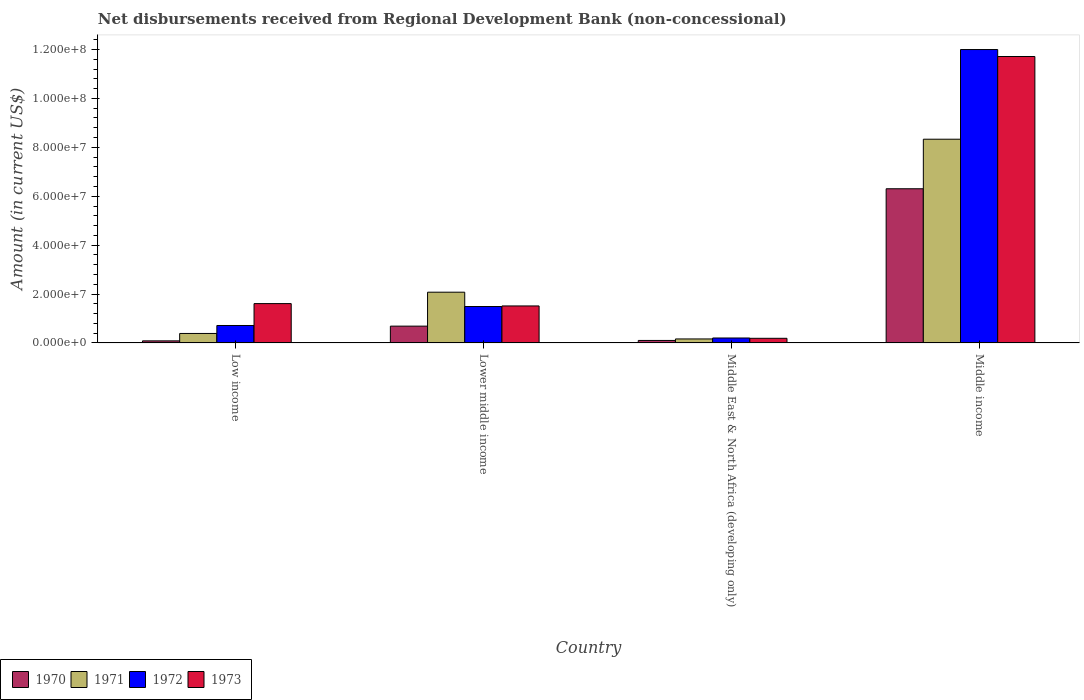Are the number of bars per tick equal to the number of legend labels?
Keep it short and to the point. Yes. How many bars are there on the 3rd tick from the left?
Provide a succinct answer. 4. How many bars are there on the 1st tick from the right?
Your answer should be compact. 4. What is the label of the 4th group of bars from the left?
Offer a terse response. Middle income. What is the amount of disbursements received from Regional Development Bank in 1973 in Middle income?
Keep it short and to the point. 1.17e+08. Across all countries, what is the maximum amount of disbursements received from Regional Development Bank in 1971?
Offer a very short reply. 8.33e+07. Across all countries, what is the minimum amount of disbursements received from Regional Development Bank in 1970?
Provide a succinct answer. 8.50e+05. In which country was the amount of disbursements received from Regional Development Bank in 1972 maximum?
Offer a terse response. Middle income. In which country was the amount of disbursements received from Regional Development Bank in 1973 minimum?
Give a very brief answer. Middle East & North Africa (developing only). What is the total amount of disbursements received from Regional Development Bank in 1970 in the graph?
Your response must be concise. 7.18e+07. What is the difference between the amount of disbursements received from Regional Development Bank in 1972 in Low income and that in Middle East & North Africa (developing only)?
Your response must be concise. 5.11e+06. What is the difference between the amount of disbursements received from Regional Development Bank in 1973 in Low income and the amount of disbursements received from Regional Development Bank in 1972 in Lower middle income?
Make the answer very short. 1.19e+06. What is the average amount of disbursements received from Regional Development Bank in 1973 per country?
Keep it short and to the point. 3.76e+07. What is the difference between the amount of disbursements received from Regional Development Bank of/in 1972 and amount of disbursements received from Regional Development Bank of/in 1973 in Middle income?
Your answer should be compact. 2.85e+06. What is the ratio of the amount of disbursements received from Regional Development Bank in 1972 in Lower middle income to that in Middle East & North Africa (developing only)?
Provide a succinct answer. 7.36. Is the amount of disbursements received from Regional Development Bank in 1973 in Low income less than that in Middle East & North Africa (developing only)?
Keep it short and to the point. No. What is the difference between the highest and the second highest amount of disbursements received from Regional Development Bank in 1970?
Keep it short and to the point. 6.20e+07. What is the difference between the highest and the lowest amount of disbursements received from Regional Development Bank in 1970?
Ensure brevity in your answer.  6.22e+07. In how many countries, is the amount of disbursements received from Regional Development Bank in 1971 greater than the average amount of disbursements received from Regional Development Bank in 1971 taken over all countries?
Ensure brevity in your answer.  1. Is the sum of the amount of disbursements received from Regional Development Bank in 1973 in Low income and Middle East & North Africa (developing only) greater than the maximum amount of disbursements received from Regional Development Bank in 1971 across all countries?
Your answer should be very brief. No. How many bars are there?
Offer a terse response. 16. How many countries are there in the graph?
Offer a very short reply. 4. What is the difference between two consecutive major ticks on the Y-axis?
Offer a terse response. 2.00e+07. Are the values on the major ticks of Y-axis written in scientific E-notation?
Your answer should be very brief. Yes. Does the graph contain grids?
Keep it short and to the point. No. Where does the legend appear in the graph?
Offer a terse response. Bottom left. What is the title of the graph?
Your response must be concise. Net disbursements received from Regional Development Bank (non-concessional). What is the label or title of the Y-axis?
Your answer should be very brief. Amount (in current US$). What is the Amount (in current US$) of 1970 in Low income?
Offer a terse response. 8.50e+05. What is the Amount (in current US$) in 1971 in Low income?
Provide a short and direct response. 3.88e+06. What is the Amount (in current US$) of 1972 in Low income?
Ensure brevity in your answer.  7.14e+06. What is the Amount (in current US$) in 1973 in Low income?
Offer a terse response. 1.61e+07. What is the Amount (in current US$) of 1970 in Lower middle income?
Give a very brief answer. 6.87e+06. What is the Amount (in current US$) in 1971 in Lower middle income?
Provide a short and direct response. 2.08e+07. What is the Amount (in current US$) of 1972 in Lower middle income?
Your answer should be compact. 1.49e+07. What is the Amount (in current US$) of 1973 in Lower middle income?
Your response must be concise. 1.51e+07. What is the Amount (in current US$) in 1970 in Middle East & North Africa (developing only)?
Provide a short and direct response. 1.02e+06. What is the Amount (in current US$) of 1971 in Middle East & North Africa (developing only)?
Provide a short and direct response. 1.64e+06. What is the Amount (in current US$) in 1972 in Middle East & North Africa (developing only)?
Offer a very short reply. 2.02e+06. What is the Amount (in current US$) in 1973 in Middle East & North Africa (developing only)?
Offer a very short reply. 1.90e+06. What is the Amount (in current US$) in 1970 in Middle income?
Offer a very short reply. 6.31e+07. What is the Amount (in current US$) of 1971 in Middle income?
Give a very brief answer. 8.33e+07. What is the Amount (in current US$) in 1972 in Middle income?
Give a very brief answer. 1.20e+08. What is the Amount (in current US$) of 1973 in Middle income?
Offer a terse response. 1.17e+08. Across all countries, what is the maximum Amount (in current US$) in 1970?
Keep it short and to the point. 6.31e+07. Across all countries, what is the maximum Amount (in current US$) of 1971?
Your response must be concise. 8.33e+07. Across all countries, what is the maximum Amount (in current US$) in 1972?
Your answer should be very brief. 1.20e+08. Across all countries, what is the maximum Amount (in current US$) in 1973?
Offer a very short reply. 1.17e+08. Across all countries, what is the minimum Amount (in current US$) of 1970?
Offer a terse response. 8.50e+05. Across all countries, what is the minimum Amount (in current US$) in 1971?
Your answer should be very brief. 1.64e+06. Across all countries, what is the minimum Amount (in current US$) of 1972?
Your answer should be very brief. 2.02e+06. Across all countries, what is the minimum Amount (in current US$) in 1973?
Offer a very short reply. 1.90e+06. What is the total Amount (in current US$) of 1970 in the graph?
Make the answer very short. 7.18e+07. What is the total Amount (in current US$) of 1971 in the graph?
Provide a short and direct response. 1.10e+08. What is the total Amount (in current US$) in 1972 in the graph?
Provide a short and direct response. 1.44e+08. What is the total Amount (in current US$) in 1973 in the graph?
Provide a succinct answer. 1.50e+08. What is the difference between the Amount (in current US$) of 1970 in Low income and that in Lower middle income?
Give a very brief answer. -6.02e+06. What is the difference between the Amount (in current US$) in 1971 in Low income and that in Lower middle income?
Your answer should be very brief. -1.69e+07. What is the difference between the Amount (in current US$) in 1972 in Low income and that in Lower middle income?
Offer a terse response. -7.76e+06. What is the difference between the Amount (in current US$) in 1973 in Low income and that in Lower middle income?
Your answer should be compact. 9.55e+05. What is the difference between the Amount (in current US$) of 1970 in Low income and that in Middle East & North Africa (developing only)?
Give a very brief answer. -1.71e+05. What is the difference between the Amount (in current US$) in 1971 in Low income and that in Middle East & North Africa (developing only)?
Your answer should be very brief. 2.24e+06. What is the difference between the Amount (in current US$) in 1972 in Low income and that in Middle East & North Africa (developing only)?
Your answer should be compact. 5.11e+06. What is the difference between the Amount (in current US$) in 1973 in Low income and that in Middle East & North Africa (developing only)?
Your answer should be very brief. 1.42e+07. What is the difference between the Amount (in current US$) of 1970 in Low income and that in Middle income?
Provide a succinct answer. -6.22e+07. What is the difference between the Amount (in current US$) of 1971 in Low income and that in Middle income?
Make the answer very short. -7.94e+07. What is the difference between the Amount (in current US$) in 1972 in Low income and that in Middle income?
Offer a very short reply. -1.13e+08. What is the difference between the Amount (in current US$) of 1973 in Low income and that in Middle income?
Your answer should be compact. -1.01e+08. What is the difference between the Amount (in current US$) of 1970 in Lower middle income and that in Middle East & North Africa (developing only)?
Ensure brevity in your answer.  5.85e+06. What is the difference between the Amount (in current US$) of 1971 in Lower middle income and that in Middle East & North Africa (developing only)?
Keep it short and to the point. 1.91e+07. What is the difference between the Amount (in current US$) in 1972 in Lower middle income and that in Middle East & North Africa (developing only)?
Your answer should be compact. 1.29e+07. What is the difference between the Amount (in current US$) in 1973 in Lower middle income and that in Middle East & North Africa (developing only)?
Your answer should be very brief. 1.32e+07. What is the difference between the Amount (in current US$) of 1970 in Lower middle income and that in Middle income?
Offer a very short reply. -5.62e+07. What is the difference between the Amount (in current US$) in 1971 in Lower middle income and that in Middle income?
Your answer should be compact. -6.26e+07. What is the difference between the Amount (in current US$) in 1972 in Lower middle income and that in Middle income?
Your response must be concise. -1.05e+08. What is the difference between the Amount (in current US$) in 1973 in Lower middle income and that in Middle income?
Keep it short and to the point. -1.02e+08. What is the difference between the Amount (in current US$) in 1970 in Middle East & North Africa (developing only) and that in Middle income?
Give a very brief answer. -6.20e+07. What is the difference between the Amount (in current US$) of 1971 in Middle East & North Africa (developing only) and that in Middle income?
Make the answer very short. -8.17e+07. What is the difference between the Amount (in current US$) in 1972 in Middle East & North Africa (developing only) and that in Middle income?
Make the answer very short. -1.18e+08. What is the difference between the Amount (in current US$) of 1973 in Middle East & North Africa (developing only) and that in Middle income?
Your response must be concise. -1.15e+08. What is the difference between the Amount (in current US$) in 1970 in Low income and the Amount (in current US$) in 1971 in Lower middle income?
Make the answer very short. -1.99e+07. What is the difference between the Amount (in current US$) of 1970 in Low income and the Amount (in current US$) of 1972 in Lower middle income?
Provide a short and direct response. -1.40e+07. What is the difference between the Amount (in current US$) in 1970 in Low income and the Amount (in current US$) in 1973 in Lower middle income?
Give a very brief answer. -1.43e+07. What is the difference between the Amount (in current US$) of 1971 in Low income and the Amount (in current US$) of 1972 in Lower middle income?
Ensure brevity in your answer.  -1.10e+07. What is the difference between the Amount (in current US$) of 1971 in Low income and the Amount (in current US$) of 1973 in Lower middle income?
Keep it short and to the point. -1.13e+07. What is the difference between the Amount (in current US$) in 1972 in Low income and the Amount (in current US$) in 1973 in Lower middle income?
Make the answer very short. -8.00e+06. What is the difference between the Amount (in current US$) of 1970 in Low income and the Amount (in current US$) of 1971 in Middle East & North Africa (developing only)?
Provide a short and direct response. -7.85e+05. What is the difference between the Amount (in current US$) in 1970 in Low income and the Amount (in current US$) in 1972 in Middle East & North Africa (developing only)?
Your answer should be very brief. -1.17e+06. What is the difference between the Amount (in current US$) of 1970 in Low income and the Amount (in current US$) of 1973 in Middle East & North Africa (developing only)?
Your answer should be compact. -1.05e+06. What is the difference between the Amount (in current US$) of 1971 in Low income and the Amount (in current US$) of 1972 in Middle East & North Africa (developing only)?
Ensure brevity in your answer.  1.85e+06. What is the difference between the Amount (in current US$) of 1971 in Low income and the Amount (in current US$) of 1973 in Middle East & North Africa (developing only)?
Provide a succinct answer. 1.98e+06. What is the difference between the Amount (in current US$) of 1972 in Low income and the Amount (in current US$) of 1973 in Middle East & North Africa (developing only)?
Ensure brevity in your answer.  5.24e+06. What is the difference between the Amount (in current US$) of 1970 in Low income and the Amount (in current US$) of 1971 in Middle income?
Ensure brevity in your answer.  -8.25e+07. What is the difference between the Amount (in current US$) in 1970 in Low income and the Amount (in current US$) in 1972 in Middle income?
Provide a short and direct response. -1.19e+08. What is the difference between the Amount (in current US$) of 1970 in Low income and the Amount (in current US$) of 1973 in Middle income?
Offer a terse response. -1.16e+08. What is the difference between the Amount (in current US$) in 1971 in Low income and the Amount (in current US$) in 1972 in Middle income?
Provide a succinct answer. -1.16e+08. What is the difference between the Amount (in current US$) of 1971 in Low income and the Amount (in current US$) of 1973 in Middle income?
Your answer should be very brief. -1.13e+08. What is the difference between the Amount (in current US$) in 1972 in Low income and the Amount (in current US$) in 1973 in Middle income?
Provide a succinct answer. -1.10e+08. What is the difference between the Amount (in current US$) in 1970 in Lower middle income and the Amount (in current US$) in 1971 in Middle East & North Africa (developing only)?
Your answer should be very brief. 5.24e+06. What is the difference between the Amount (in current US$) of 1970 in Lower middle income and the Amount (in current US$) of 1972 in Middle East & North Africa (developing only)?
Ensure brevity in your answer.  4.85e+06. What is the difference between the Amount (in current US$) of 1970 in Lower middle income and the Amount (in current US$) of 1973 in Middle East & North Africa (developing only)?
Give a very brief answer. 4.98e+06. What is the difference between the Amount (in current US$) of 1971 in Lower middle income and the Amount (in current US$) of 1972 in Middle East & North Africa (developing only)?
Give a very brief answer. 1.87e+07. What is the difference between the Amount (in current US$) in 1971 in Lower middle income and the Amount (in current US$) in 1973 in Middle East & North Africa (developing only)?
Your answer should be very brief. 1.89e+07. What is the difference between the Amount (in current US$) in 1972 in Lower middle income and the Amount (in current US$) in 1973 in Middle East & North Africa (developing only)?
Make the answer very short. 1.30e+07. What is the difference between the Amount (in current US$) of 1970 in Lower middle income and the Amount (in current US$) of 1971 in Middle income?
Your response must be concise. -7.65e+07. What is the difference between the Amount (in current US$) of 1970 in Lower middle income and the Amount (in current US$) of 1972 in Middle income?
Offer a very short reply. -1.13e+08. What is the difference between the Amount (in current US$) in 1970 in Lower middle income and the Amount (in current US$) in 1973 in Middle income?
Provide a succinct answer. -1.10e+08. What is the difference between the Amount (in current US$) in 1971 in Lower middle income and the Amount (in current US$) in 1972 in Middle income?
Make the answer very short. -9.92e+07. What is the difference between the Amount (in current US$) of 1971 in Lower middle income and the Amount (in current US$) of 1973 in Middle income?
Give a very brief answer. -9.64e+07. What is the difference between the Amount (in current US$) in 1972 in Lower middle income and the Amount (in current US$) in 1973 in Middle income?
Ensure brevity in your answer.  -1.02e+08. What is the difference between the Amount (in current US$) of 1970 in Middle East & North Africa (developing only) and the Amount (in current US$) of 1971 in Middle income?
Make the answer very short. -8.23e+07. What is the difference between the Amount (in current US$) in 1970 in Middle East & North Africa (developing only) and the Amount (in current US$) in 1972 in Middle income?
Provide a short and direct response. -1.19e+08. What is the difference between the Amount (in current US$) of 1970 in Middle East & North Africa (developing only) and the Amount (in current US$) of 1973 in Middle income?
Provide a succinct answer. -1.16e+08. What is the difference between the Amount (in current US$) in 1971 in Middle East & North Africa (developing only) and the Amount (in current US$) in 1972 in Middle income?
Offer a very short reply. -1.18e+08. What is the difference between the Amount (in current US$) in 1971 in Middle East & North Africa (developing only) and the Amount (in current US$) in 1973 in Middle income?
Make the answer very short. -1.16e+08. What is the difference between the Amount (in current US$) of 1972 in Middle East & North Africa (developing only) and the Amount (in current US$) of 1973 in Middle income?
Ensure brevity in your answer.  -1.15e+08. What is the average Amount (in current US$) in 1970 per country?
Provide a succinct answer. 1.79e+07. What is the average Amount (in current US$) of 1971 per country?
Offer a terse response. 2.74e+07. What is the average Amount (in current US$) in 1972 per country?
Your response must be concise. 3.60e+07. What is the average Amount (in current US$) in 1973 per country?
Your response must be concise. 3.76e+07. What is the difference between the Amount (in current US$) of 1970 and Amount (in current US$) of 1971 in Low income?
Offer a very short reply. -3.02e+06. What is the difference between the Amount (in current US$) of 1970 and Amount (in current US$) of 1972 in Low income?
Ensure brevity in your answer.  -6.29e+06. What is the difference between the Amount (in current US$) in 1970 and Amount (in current US$) in 1973 in Low income?
Give a very brief answer. -1.52e+07. What is the difference between the Amount (in current US$) in 1971 and Amount (in current US$) in 1972 in Low income?
Offer a terse response. -3.26e+06. What is the difference between the Amount (in current US$) of 1971 and Amount (in current US$) of 1973 in Low income?
Make the answer very short. -1.22e+07. What is the difference between the Amount (in current US$) in 1972 and Amount (in current US$) in 1973 in Low income?
Your response must be concise. -8.95e+06. What is the difference between the Amount (in current US$) in 1970 and Amount (in current US$) in 1971 in Lower middle income?
Keep it short and to the point. -1.39e+07. What is the difference between the Amount (in current US$) of 1970 and Amount (in current US$) of 1972 in Lower middle income?
Make the answer very short. -8.03e+06. What is the difference between the Amount (in current US$) in 1970 and Amount (in current US$) in 1973 in Lower middle income?
Keep it short and to the point. -8.26e+06. What is the difference between the Amount (in current US$) in 1971 and Amount (in current US$) in 1972 in Lower middle income?
Provide a succinct answer. 5.85e+06. What is the difference between the Amount (in current US$) in 1971 and Amount (in current US$) in 1973 in Lower middle income?
Your response must be concise. 5.62e+06. What is the difference between the Amount (in current US$) of 1972 and Amount (in current US$) of 1973 in Lower middle income?
Give a very brief answer. -2.36e+05. What is the difference between the Amount (in current US$) in 1970 and Amount (in current US$) in 1971 in Middle East & North Africa (developing only)?
Ensure brevity in your answer.  -6.14e+05. What is the difference between the Amount (in current US$) of 1970 and Amount (in current US$) of 1972 in Middle East & North Africa (developing only)?
Your response must be concise. -1.00e+06. What is the difference between the Amount (in current US$) of 1970 and Amount (in current US$) of 1973 in Middle East & North Africa (developing only)?
Make the answer very short. -8.75e+05. What is the difference between the Amount (in current US$) in 1971 and Amount (in current US$) in 1972 in Middle East & North Africa (developing only)?
Ensure brevity in your answer.  -3.89e+05. What is the difference between the Amount (in current US$) in 1971 and Amount (in current US$) in 1973 in Middle East & North Africa (developing only)?
Provide a short and direct response. -2.61e+05. What is the difference between the Amount (in current US$) of 1972 and Amount (in current US$) of 1973 in Middle East & North Africa (developing only)?
Offer a terse response. 1.28e+05. What is the difference between the Amount (in current US$) in 1970 and Amount (in current US$) in 1971 in Middle income?
Offer a terse response. -2.03e+07. What is the difference between the Amount (in current US$) of 1970 and Amount (in current US$) of 1972 in Middle income?
Your answer should be compact. -5.69e+07. What is the difference between the Amount (in current US$) in 1970 and Amount (in current US$) in 1973 in Middle income?
Provide a short and direct response. -5.41e+07. What is the difference between the Amount (in current US$) in 1971 and Amount (in current US$) in 1972 in Middle income?
Offer a very short reply. -3.67e+07. What is the difference between the Amount (in current US$) in 1971 and Amount (in current US$) in 1973 in Middle income?
Your answer should be compact. -3.38e+07. What is the difference between the Amount (in current US$) in 1972 and Amount (in current US$) in 1973 in Middle income?
Make the answer very short. 2.85e+06. What is the ratio of the Amount (in current US$) in 1970 in Low income to that in Lower middle income?
Make the answer very short. 0.12. What is the ratio of the Amount (in current US$) in 1971 in Low income to that in Lower middle income?
Your answer should be compact. 0.19. What is the ratio of the Amount (in current US$) of 1972 in Low income to that in Lower middle income?
Your answer should be compact. 0.48. What is the ratio of the Amount (in current US$) in 1973 in Low income to that in Lower middle income?
Your answer should be compact. 1.06. What is the ratio of the Amount (in current US$) of 1970 in Low income to that in Middle East & North Africa (developing only)?
Your answer should be very brief. 0.83. What is the ratio of the Amount (in current US$) of 1971 in Low income to that in Middle East & North Africa (developing only)?
Offer a terse response. 2.37. What is the ratio of the Amount (in current US$) of 1972 in Low income to that in Middle East & North Africa (developing only)?
Make the answer very short. 3.53. What is the ratio of the Amount (in current US$) of 1973 in Low income to that in Middle East & North Africa (developing only)?
Offer a terse response. 8.49. What is the ratio of the Amount (in current US$) in 1970 in Low income to that in Middle income?
Ensure brevity in your answer.  0.01. What is the ratio of the Amount (in current US$) of 1971 in Low income to that in Middle income?
Your response must be concise. 0.05. What is the ratio of the Amount (in current US$) in 1972 in Low income to that in Middle income?
Offer a very short reply. 0.06. What is the ratio of the Amount (in current US$) of 1973 in Low income to that in Middle income?
Your response must be concise. 0.14. What is the ratio of the Amount (in current US$) in 1970 in Lower middle income to that in Middle East & North Africa (developing only)?
Offer a terse response. 6.73. What is the ratio of the Amount (in current US$) in 1971 in Lower middle income to that in Middle East & North Africa (developing only)?
Give a very brief answer. 12.69. What is the ratio of the Amount (in current US$) in 1972 in Lower middle income to that in Middle East & North Africa (developing only)?
Offer a very short reply. 7.36. What is the ratio of the Amount (in current US$) in 1973 in Lower middle income to that in Middle East & North Africa (developing only)?
Keep it short and to the point. 7.98. What is the ratio of the Amount (in current US$) of 1970 in Lower middle income to that in Middle income?
Offer a very short reply. 0.11. What is the ratio of the Amount (in current US$) in 1971 in Lower middle income to that in Middle income?
Your response must be concise. 0.25. What is the ratio of the Amount (in current US$) in 1972 in Lower middle income to that in Middle income?
Your answer should be very brief. 0.12. What is the ratio of the Amount (in current US$) in 1973 in Lower middle income to that in Middle income?
Your answer should be very brief. 0.13. What is the ratio of the Amount (in current US$) of 1970 in Middle East & North Africa (developing only) to that in Middle income?
Provide a short and direct response. 0.02. What is the ratio of the Amount (in current US$) of 1971 in Middle East & North Africa (developing only) to that in Middle income?
Make the answer very short. 0.02. What is the ratio of the Amount (in current US$) of 1972 in Middle East & North Africa (developing only) to that in Middle income?
Provide a short and direct response. 0.02. What is the ratio of the Amount (in current US$) of 1973 in Middle East & North Africa (developing only) to that in Middle income?
Keep it short and to the point. 0.02. What is the difference between the highest and the second highest Amount (in current US$) in 1970?
Offer a terse response. 5.62e+07. What is the difference between the highest and the second highest Amount (in current US$) in 1971?
Offer a very short reply. 6.26e+07. What is the difference between the highest and the second highest Amount (in current US$) in 1972?
Your answer should be compact. 1.05e+08. What is the difference between the highest and the second highest Amount (in current US$) of 1973?
Provide a short and direct response. 1.01e+08. What is the difference between the highest and the lowest Amount (in current US$) in 1970?
Keep it short and to the point. 6.22e+07. What is the difference between the highest and the lowest Amount (in current US$) of 1971?
Provide a succinct answer. 8.17e+07. What is the difference between the highest and the lowest Amount (in current US$) in 1972?
Provide a succinct answer. 1.18e+08. What is the difference between the highest and the lowest Amount (in current US$) of 1973?
Keep it short and to the point. 1.15e+08. 